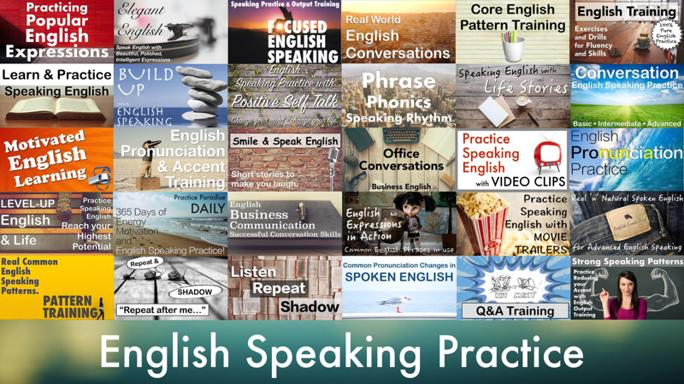How can phonics and rhythm training specifically improve English pronunciation? Phonics training helps learners understand the sounds of English, enabling them to accurately produce these sounds. Rhythm training, on the other hand, aids in grasping the natural flow and stress patterns of the language, which are crucial for clear and effective communication. Are there specific exercises mentioned in the image for phonics training? Yes, the image suggests 'Pronunciation Practice' and 'Repeat after me…' exercises which are likely to involve phonics training by repeating sounds and phrases to master the pronunciation of words. 